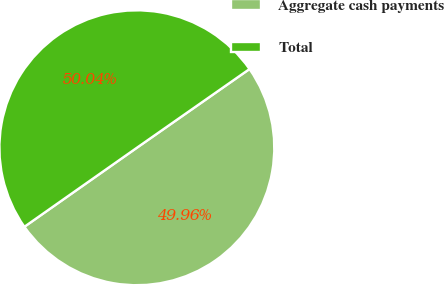Convert chart. <chart><loc_0><loc_0><loc_500><loc_500><pie_chart><fcel>Aggregate cash payments<fcel>Total<nl><fcel>49.96%<fcel>50.04%<nl></chart> 